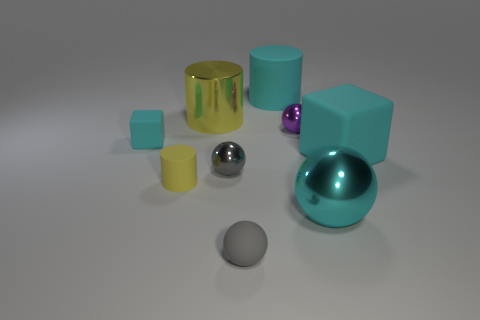What is the material of the small thing that is the same color as the large block?
Offer a terse response. Rubber. Does the big rubber object that is on the right side of the big cyan metallic thing have the same color as the large matte thing that is left of the large cyan metallic object?
Your answer should be compact. Yes. Are there fewer big cyan cubes that are behind the tiny gray rubber object than small shiny things that are behind the cyan shiny object?
Provide a short and direct response. Yes. How many spheres are cyan rubber things or tiny yellow objects?
Your answer should be compact. 0. Is the material of the cube on the right side of the cyan cylinder the same as the large cyan ball in front of the tiny purple thing?
Your answer should be very brief. No. What shape is the purple metal object that is the same size as the gray matte sphere?
Your answer should be very brief. Sphere. How many other things are there of the same color as the large rubber block?
Keep it short and to the point. 3. What number of purple objects are small balls or rubber balls?
Provide a succinct answer. 1. There is a tiny purple object behind the tiny yellow thing; is its shape the same as the large shiny thing in front of the tiny gray shiny thing?
Make the answer very short. Yes. What number of other objects are the same material as the tiny cyan block?
Your response must be concise. 4. 